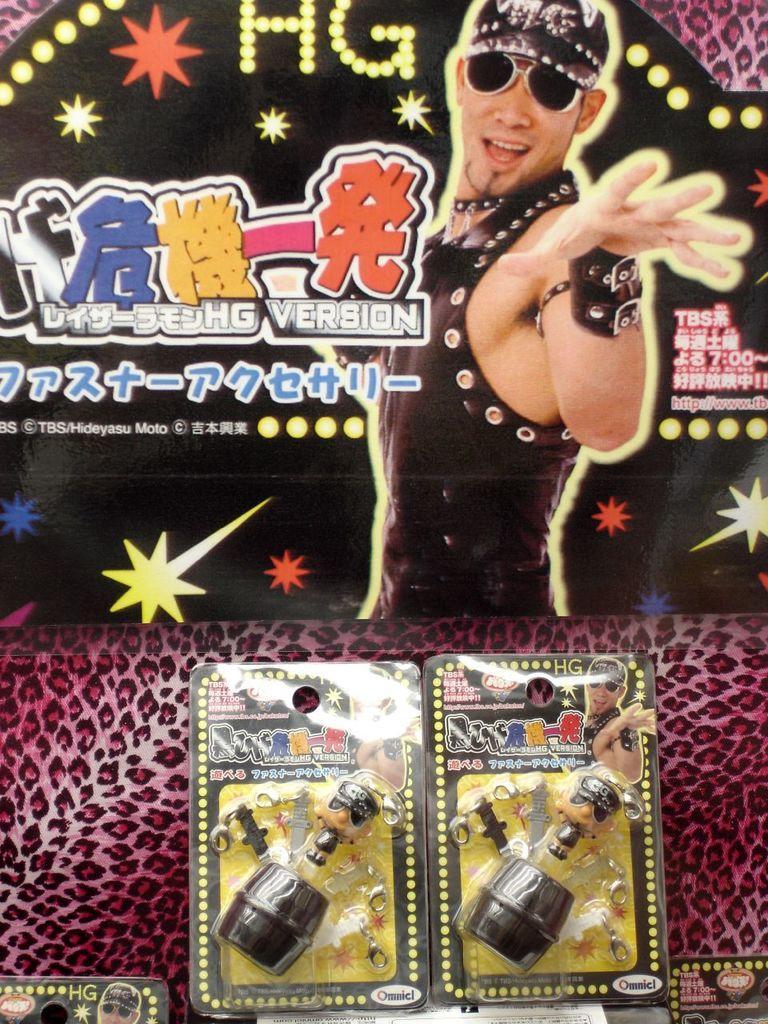How would you summarize this image in a sentence or two? In this image we can see some toys placed on the surface. In the background, we can see a poster with a picture and some text. 